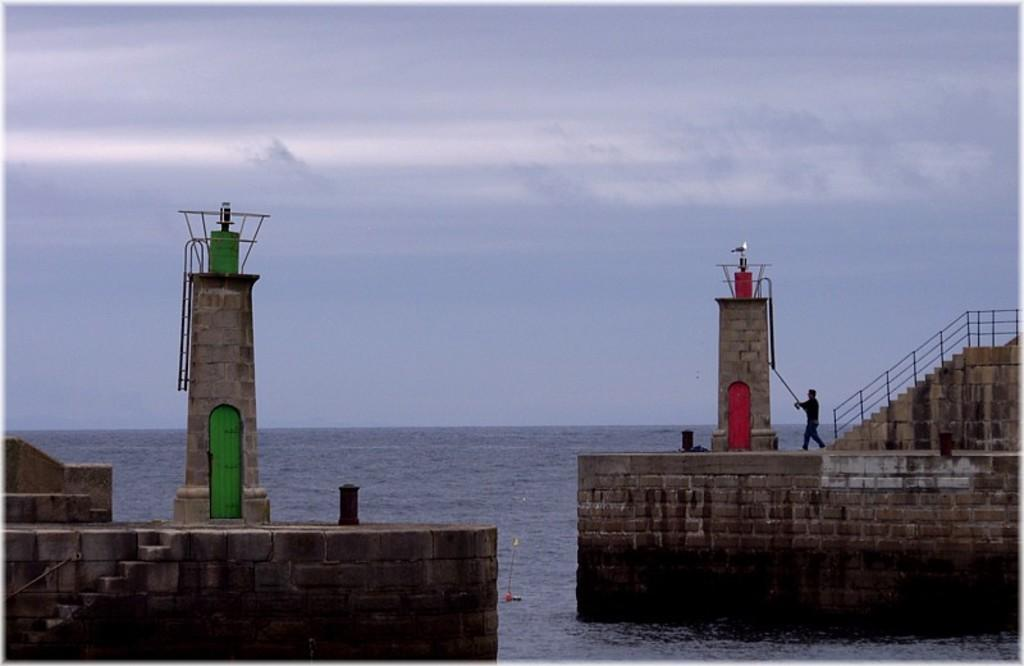What is the weather like in the image? The sky in the image is cloudy. What type of natural feature can be seen in the image? There is water visible in the image. What type of structure is present in the image? There are lighthouses in the image. What architectural elements can be seen in the image? There are walls, a railing, and steps in the image. Is there a person present in the image? Yes, there is a person in the image. What type of screw is being used by the achiever in the image? There is no screw or achiever present in the image. 